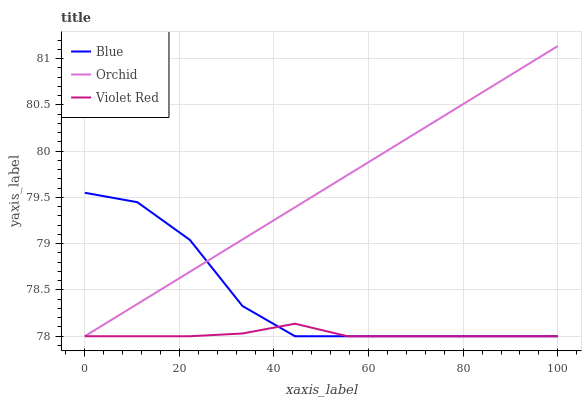Does Orchid have the minimum area under the curve?
Answer yes or no. No. Does Violet Red have the maximum area under the curve?
Answer yes or no. No. Is Violet Red the smoothest?
Answer yes or no. No. Is Violet Red the roughest?
Answer yes or no. No. Does Violet Red have the highest value?
Answer yes or no. No. 